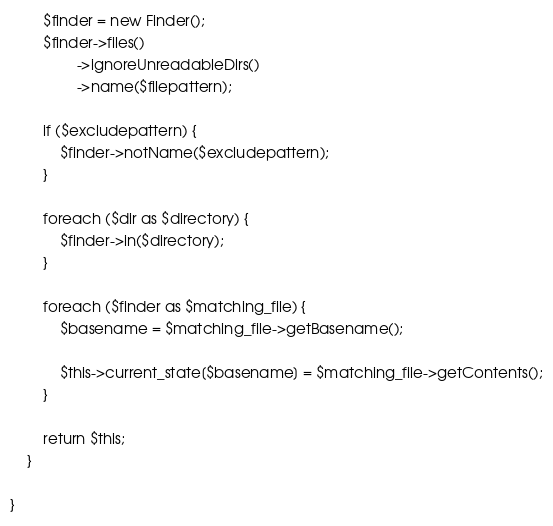<code> <loc_0><loc_0><loc_500><loc_500><_PHP_>
        $finder = new Finder();
        $finder->files()
                ->ignoreUnreadableDirs()
                ->name($filepattern);

        if ($excludepattern) {
            $finder->notName($excludepattern);
        }

        foreach ($dir as $directory) {
            $finder->in($directory);
        }

        foreach ($finder as $matching_file) {
            $basename = $matching_file->getBasename();

            $this->current_state[$basename] = $matching_file->getContents();
        }

        return $this;
    }

}
</code> 